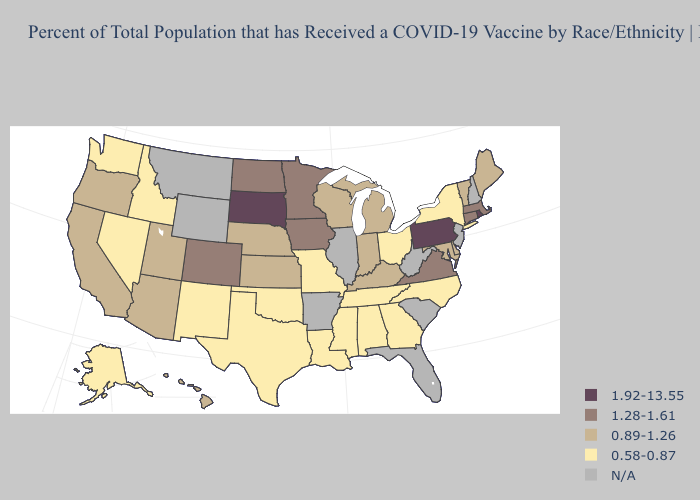Which states hav the highest value in the Northeast?
Write a very short answer. Pennsylvania, Rhode Island. Name the states that have a value in the range N/A?
Keep it brief. Arkansas, Florida, Illinois, Montana, New Hampshire, New Jersey, South Carolina, West Virginia, Wyoming. Name the states that have a value in the range 1.28-1.61?
Answer briefly. Colorado, Connecticut, Iowa, Massachusetts, Minnesota, North Dakota, Virginia. What is the value of Wyoming?
Give a very brief answer. N/A. Name the states that have a value in the range 0.58-0.87?
Concise answer only. Alabama, Alaska, Georgia, Idaho, Louisiana, Mississippi, Missouri, Nevada, New Mexico, New York, North Carolina, Ohio, Oklahoma, Tennessee, Texas, Washington. What is the lowest value in the USA?
Give a very brief answer. 0.58-0.87. Name the states that have a value in the range 0.89-1.26?
Write a very short answer. Arizona, California, Delaware, Hawaii, Indiana, Kansas, Kentucky, Maine, Maryland, Michigan, Nebraska, Oregon, Utah, Vermont, Wisconsin. What is the value of Nebraska?
Write a very short answer. 0.89-1.26. Does Tennessee have the lowest value in the South?
Concise answer only. Yes. What is the value of Utah?
Give a very brief answer. 0.89-1.26. Among the states that border West Virginia , which have the lowest value?
Short answer required. Ohio. What is the value of California?
Keep it brief. 0.89-1.26. 